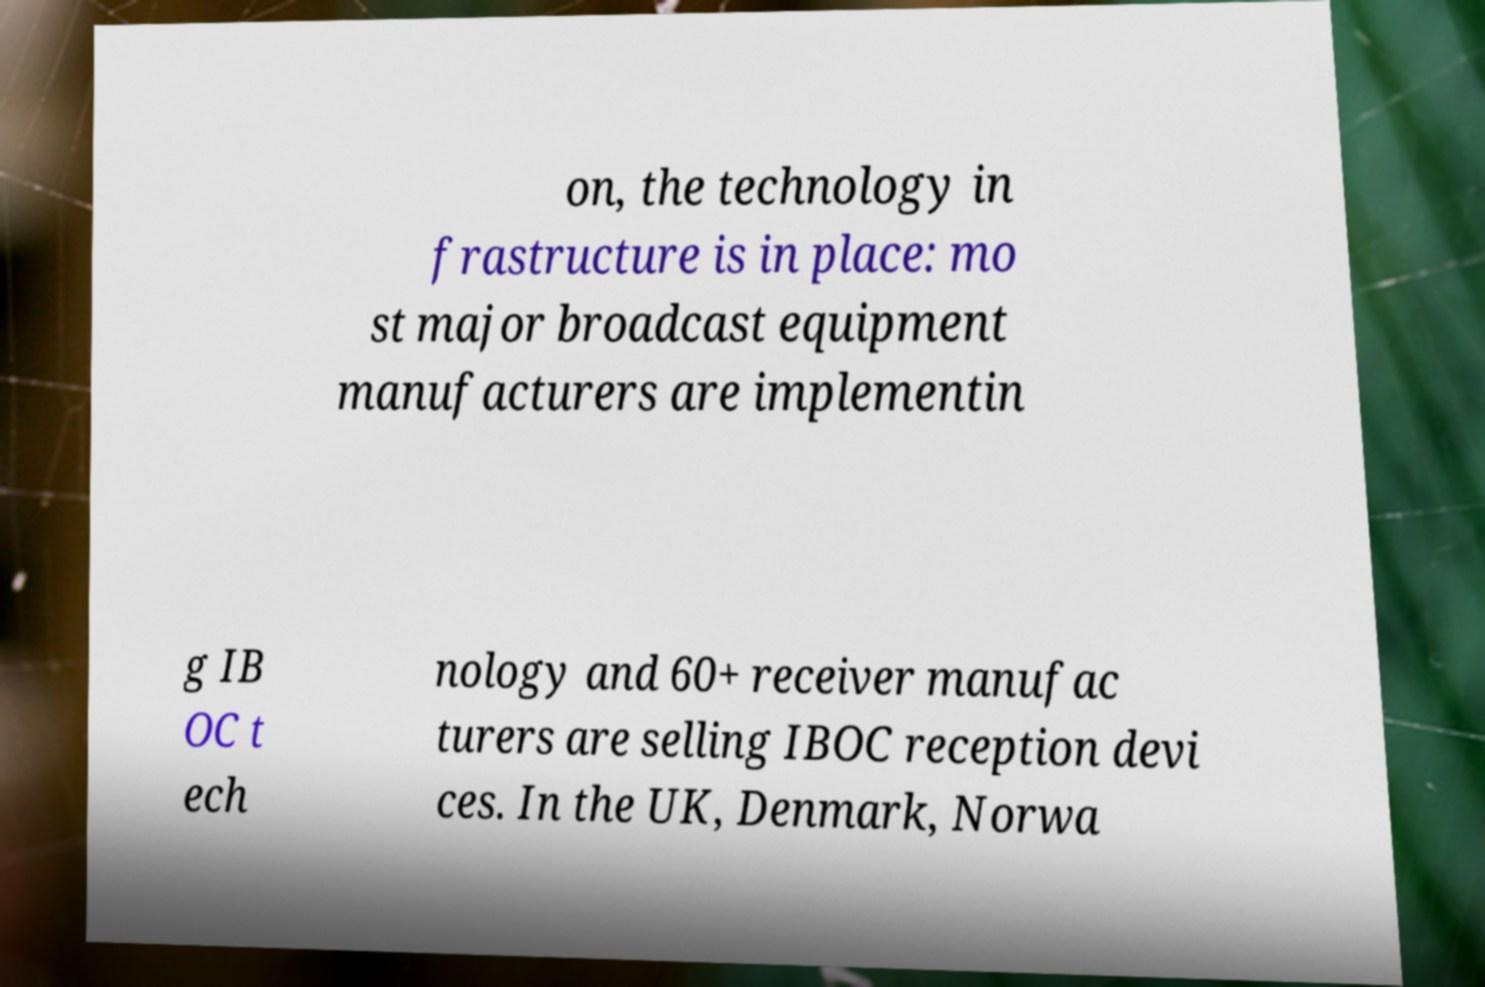What messages or text are displayed in this image? I need them in a readable, typed format. on, the technology in frastructure is in place: mo st major broadcast equipment manufacturers are implementin g IB OC t ech nology and 60+ receiver manufac turers are selling IBOC reception devi ces. In the UK, Denmark, Norwa 